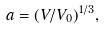<formula> <loc_0><loc_0><loc_500><loc_500>a = ( V / V _ { 0 } ) ^ { 1 / 3 } ,</formula> 